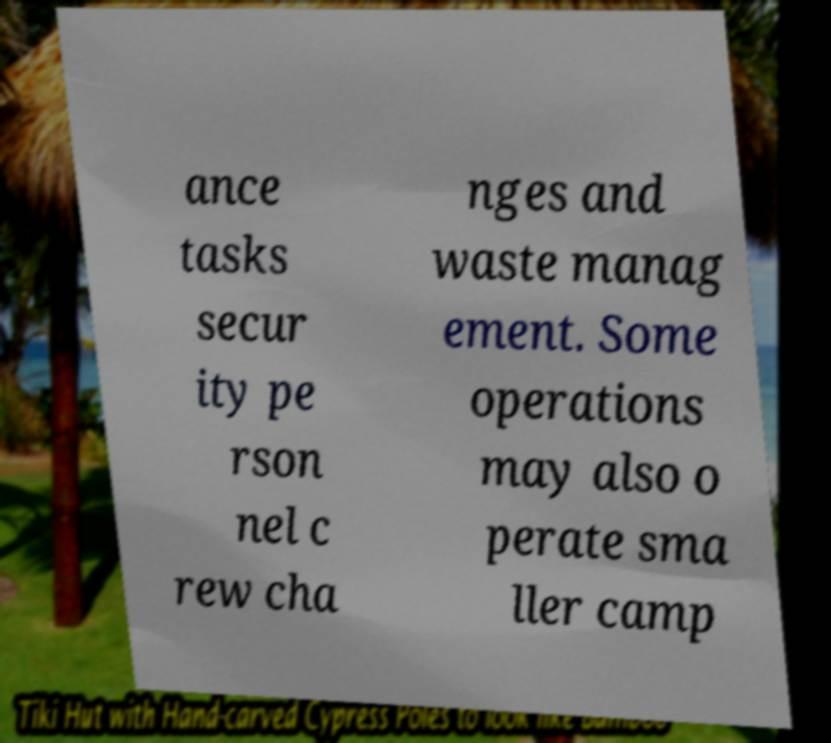What messages or text are displayed in this image? I need them in a readable, typed format. ance tasks secur ity pe rson nel c rew cha nges and waste manag ement. Some operations may also o perate sma ller camp 